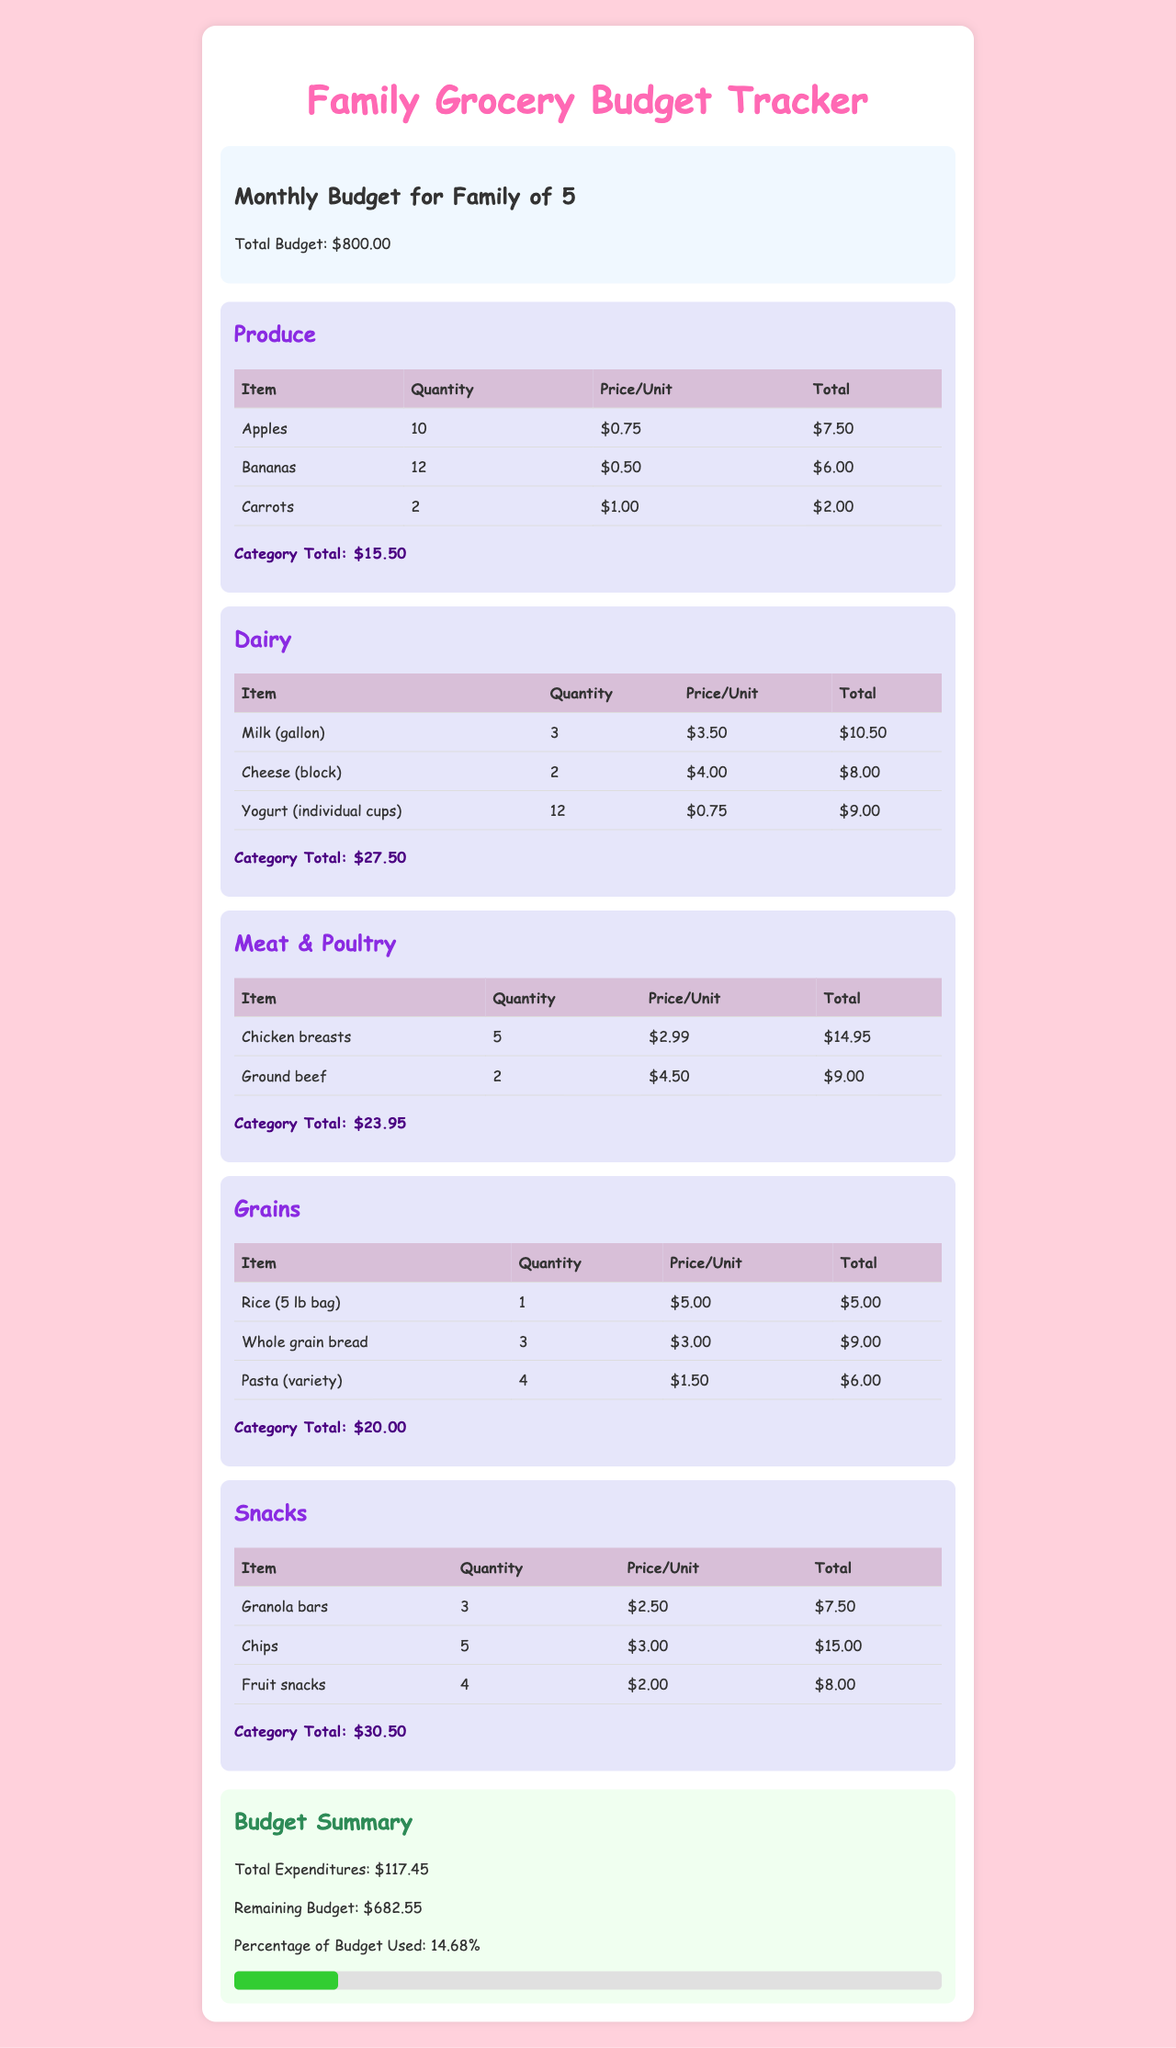what is the total budget? The total budget for the family of five is specified in the budget information section as $800.00.
Answer: $800.00 what is the category total for dairy? The dairy section has its own category total listed as $27.50.
Answer: $27.50 how many apples are listed in the produce category? The produce category lists 10 apples as part of the items purchased.
Answer: 10 what is the total expenditure for snacks? The snacks category shows a total expenditure listed as $30.50.
Answer: $30.50 what percentage of the budget has been used? The documents detail that 14.68% of the budget has been utilized based on total expenditures and the budget.
Answer: 14.68% what is the total amount spent on meat and poultry? The category total for meat and poultry sums up to $23.95, which includes the expenditures for chicken breasts and ground beef.
Answer: $23.95 how many units of granola bars were purchased? The snacks section specifies that 3 granola bars were purchased, which is listed under the snacks category items.
Answer: 3 what is the total remaining budget after expenditures? The remaining budget, calculated from total expenditures, is stated as $682.55.
Answer: $682.55 what is the price per unit for cheese? In the dairy category, the price per unit for cheese is indicated as $4.00.
Answer: $4.00 